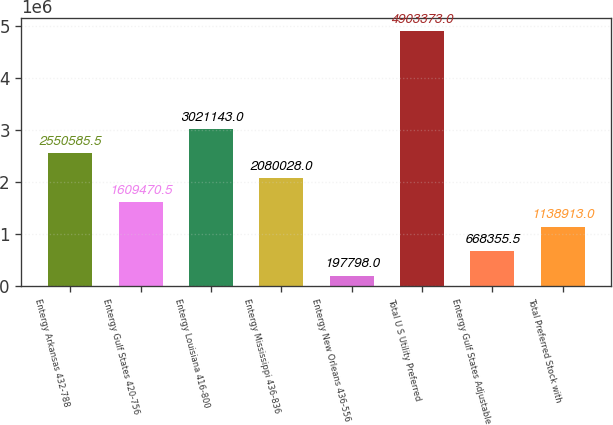Convert chart. <chart><loc_0><loc_0><loc_500><loc_500><bar_chart><fcel>Entergy Arkansas 432-788<fcel>Entergy Gulf States 420-756<fcel>Entergy Louisiana 416-800<fcel>Entergy Mississippi 436-836<fcel>Entergy New Orleans 436-556<fcel>Total U S Utility Preferred<fcel>Entergy Gulf States Adjustable<fcel>Total Preferred Stock with<nl><fcel>2.55059e+06<fcel>1.60947e+06<fcel>3.02114e+06<fcel>2.08003e+06<fcel>197798<fcel>4.90337e+06<fcel>668356<fcel>1.13891e+06<nl></chart> 